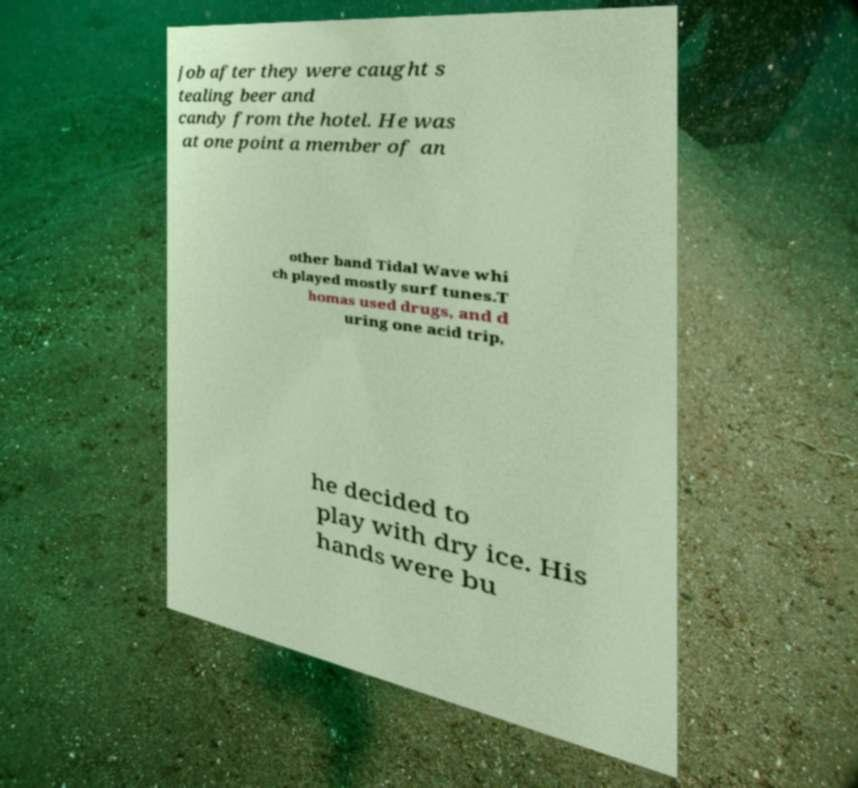Can you read and provide the text displayed in the image?This photo seems to have some interesting text. Can you extract and type it out for me? job after they were caught s tealing beer and candy from the hotel. He was at one point a member of an other band Tidal Wave whi ch played mostly surf tunes.T homas used drugs, and d uring one acid trip, he decided to play with dry ice. His hands were bu 